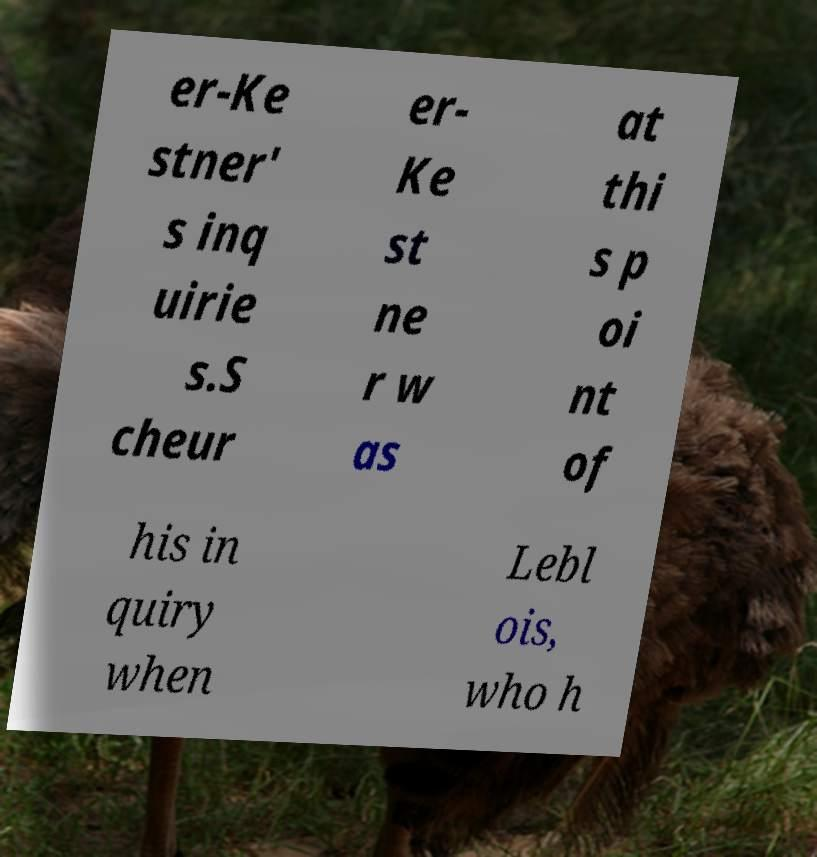Please identify and transcribe the text found in this image. er-Ke stner' s inq uirie s.S cheur er- Ke st ne r w as at thi s p oi nt of his in quiry when Lebl ois, who h 